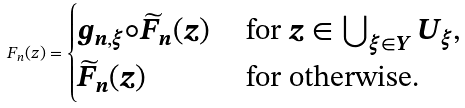<formula> <loc_0><loc_0><loc_500><loc_500>F _ { n } ( z ) = \begin{cases} g _ { n , \xi } \circ \widetilde { F } _ { n } ( z ) & \text { for $z \in \bigcup_{\xi \in Y}U_{\xi}$} , \\ \widetilde { F } _ { n } ( z ) & \text { for otherwise} . \end{cases}</formula> 